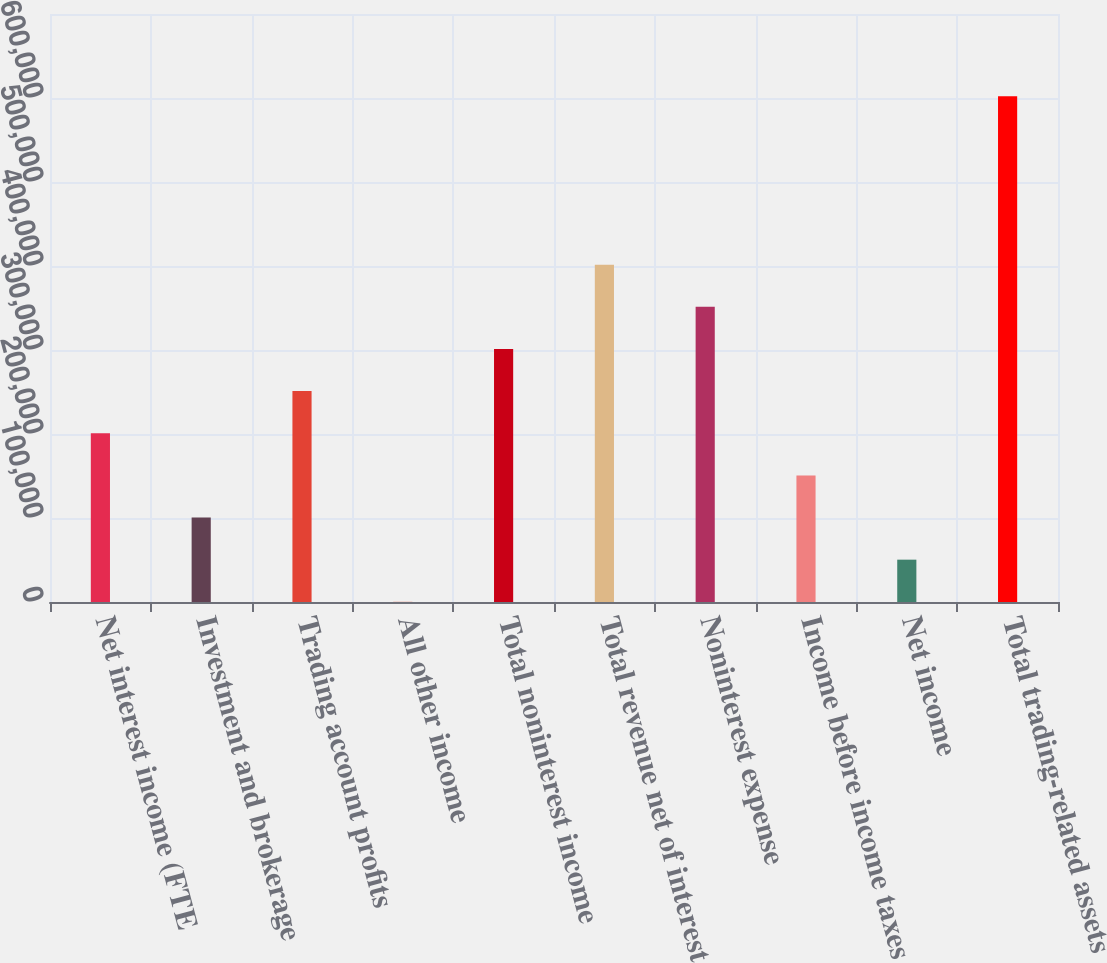Convert chart. <chart><loc_0><loc_0><loc_500><loc_500><bar_chart><fcel>Net interest income (FTE<fcel>Investment and brokerage<fcel>Trading account profits<fcel>All other income<fcel>Total noninterest income<fcel>Total revenue net of interest<fcel>Noninterest expense<fcel>Income before income taxes<fcel>Net income<fcel>Total trading-related assets<nl><fcel>200888<fcel>100562<fcel>251052<fcel>236<fcel>301215<fcel>401541<fcel>351378<fcel>150725<fcel>50399.1<fcel>602193<nl></chart> 